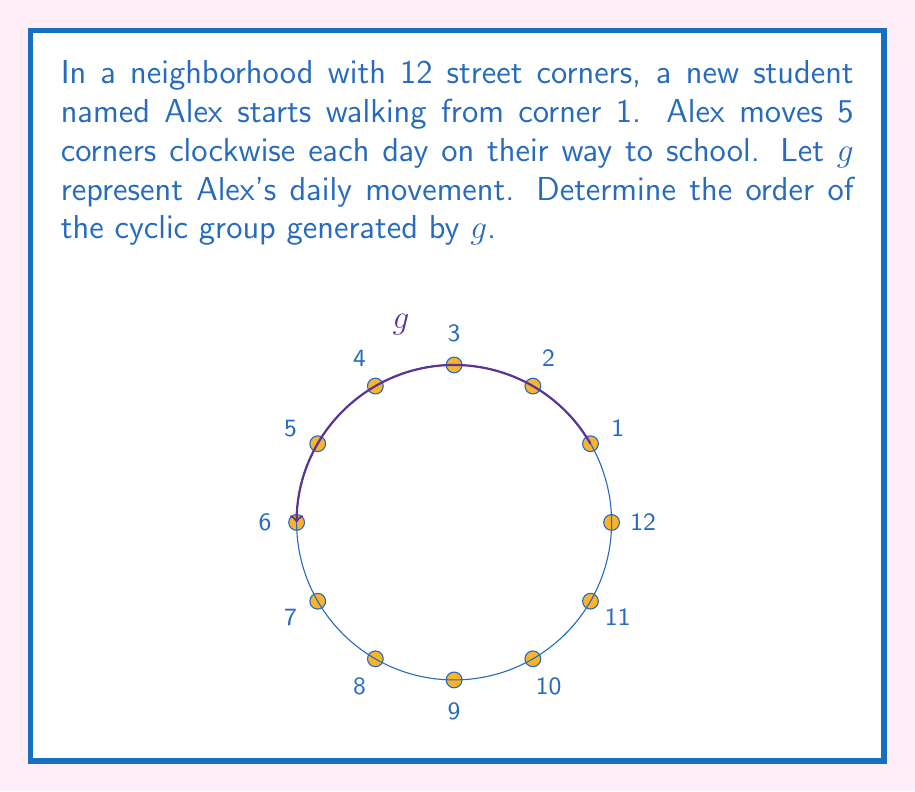Can you answer this question? Let's approach this step-by-step:

1) The order of a cyclic group is the smallest positive integer $n$ such that $g^n = e$, where $e$ is the identity element.

2) In this case, $e$ would be returning to the starting point (corner 1).

3) Let's see what happens as we apply $g$ multiple times:
   $g^1$: 1 → 6
   $g^2$: 1 → 6 → 11
   $g^3$: 1 → 6 → 11 → 4
   $g^4$: 1 → 6 → 11 → 4 → 9
   $g^5$: 1 → 6 → 11 → 4 → 9 → 2
   $g^6$: 1 → 6 → 11 → 4 → 9 → 2 → 7
   $g^7$: 1 → 6 → 11 → 4 → 9 → 2 → 7 → 12
   $g^8$: 1 → 6 → 11 → 4 → 9 → 2 → 7 → 12 → 5
   $g^9$: 1 → 6 → 11 → 4 → 9 → 2 → 7 → 12 → 5 → 10
   $g^{10}$: 1 → 6 → 11 → 4 → 9 → 2 → 7 → 12 → 5 → 10 → 3
   $g^{11}$: 1 → 6 → 11 → 4 → 9 → 2 → 7 → 12 → 5 → 10 → 3 → 8
   $g^{12}$: 1 → 6 → 11 → 4 → 9 → 2 → 7 → 12 → 5 → 10 → 3 → 8 → 1

4) We see that $g^{12} = e$, and this is the smallest positive integer for which this is true.

5) Therefore, the order of the cyclic group generated by $g$ is 12.
Answer: 12 